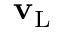Convert formula to latex. <formula><loc_0><loc_0><loc_500><loc_500>{ v } _ { L }</formula> 